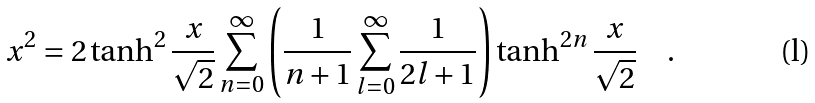<formula> <loc_0><loc_0><loc_500><loc_500>x ^ { 2 } = 2 \tanh ^ { 2 } \frac { x } { \sqrt { 2 } } \sum _ { n = 0 } ^ { \infty } \left ( \frac { 1 } { n + 1 } \sum _ { l = 0 } ^ { \infty } \frac { 1 } { 2 l + 1 } \right ) \tanh ^ { 2 n } \frac { x } { \sqrt { 2 } } \quad .</formula> 